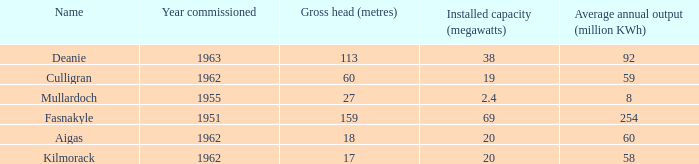For a culligran power station with an installed capacity under 19, what is the average output per year? None. 